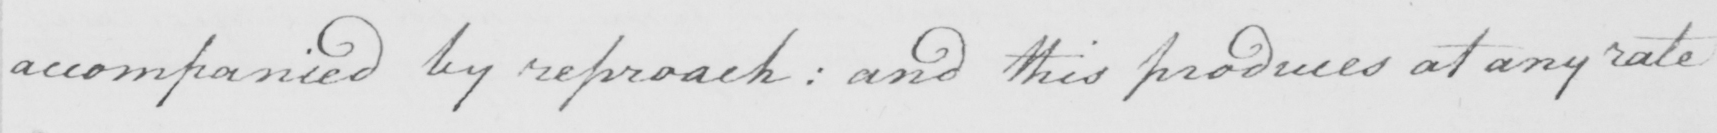Transcribe the text shown in this historical manuscript line. accompanied by reproach :  and this produces at any rate 